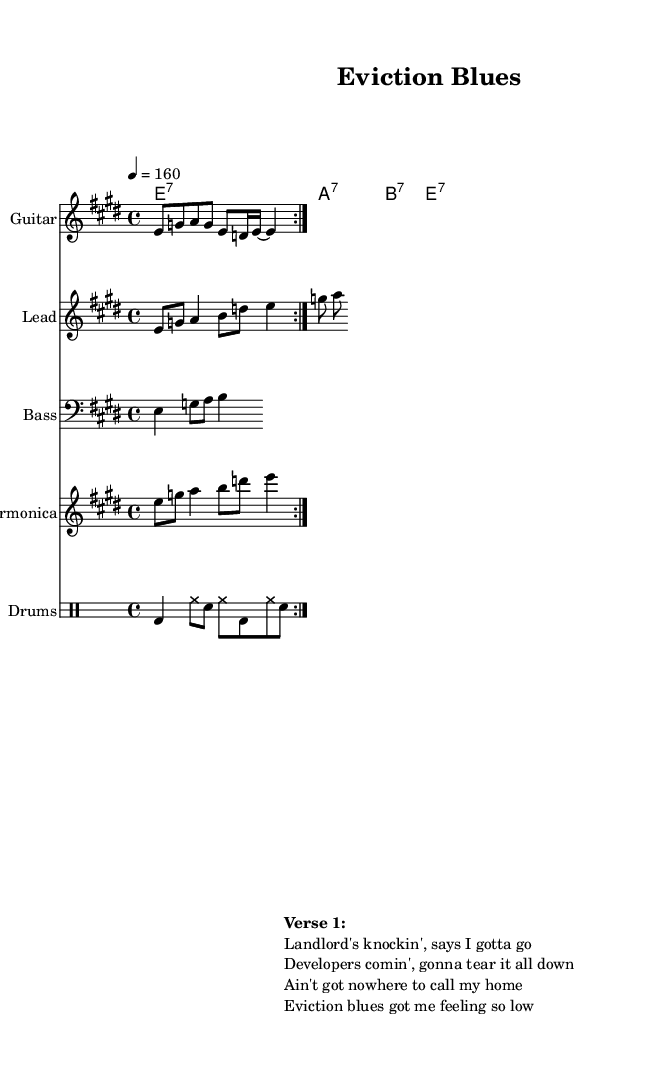What is the key signature of this music? The key signature is E major, which has four sharps (F#, C#, G#, D#).
Answer: E major What is the time signature of this music? The time signature is 4/4, meaning there are four beats in each measure and the quarter note gets one beat.
Answer: 4/4 What is the tempo marking? The tempo marking is 160 beats per minute, indicated by the tempo statement "4 = 160".
Answer: 160 What instruments are featured in this composition? The instruments featured are Guitar, Lead, Bass, Harmonica, and Drums, as indicated by the staff names.
Answer: Guitar, Lead, Bass, Harmonica, Drums How many times is the guitar riff repeated? The guitar riff is repeated twice, as indicated by the "repeat volta 2" instruction.
Answer: Twice What is the primary theme expressed in the lyrics? The primary theme expressed is frustration with landlords and property developers, focusing on the experience of eviction.
Answer: Frustration with landlords and property developers What is the role of the harmonica in this piece? The harmonica plays a solo, providing an additional melodic element to the composition, and it is labeled as "Harmonica".
Answer: Harmonica solo 